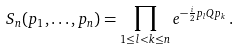Convert formula to latex. <formula><loc_0><loc_0><loc_500><loc_500>S _ { n } ( p _ { 1 } , \dots , p _ { n } ) & = \prod _ { 1 \leq l < k \leq n } e ^ { - \frac { i } { 2 } p _ { l } Q p _ { k } } \, .</formula> 